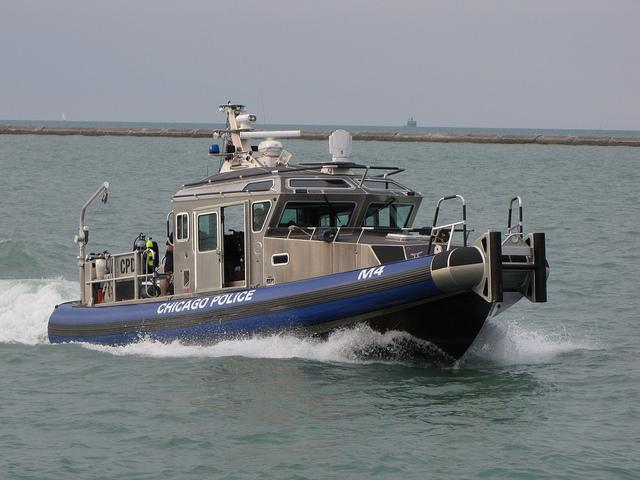What city is this boat from?
Answer briefly. Chicago. What department does this boat belong to?
Be succinct. Chicago police. What print is on the speed boat?
Keep it brief. Chicago police. How many birds are in the picture?
Short answer required. 0. Where is the boat?
Quick response, please. Water. 